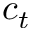Convert formula to latex. <formula><loc_0><loc_0><loc_500><loc_500>c _ { t }</formula> 